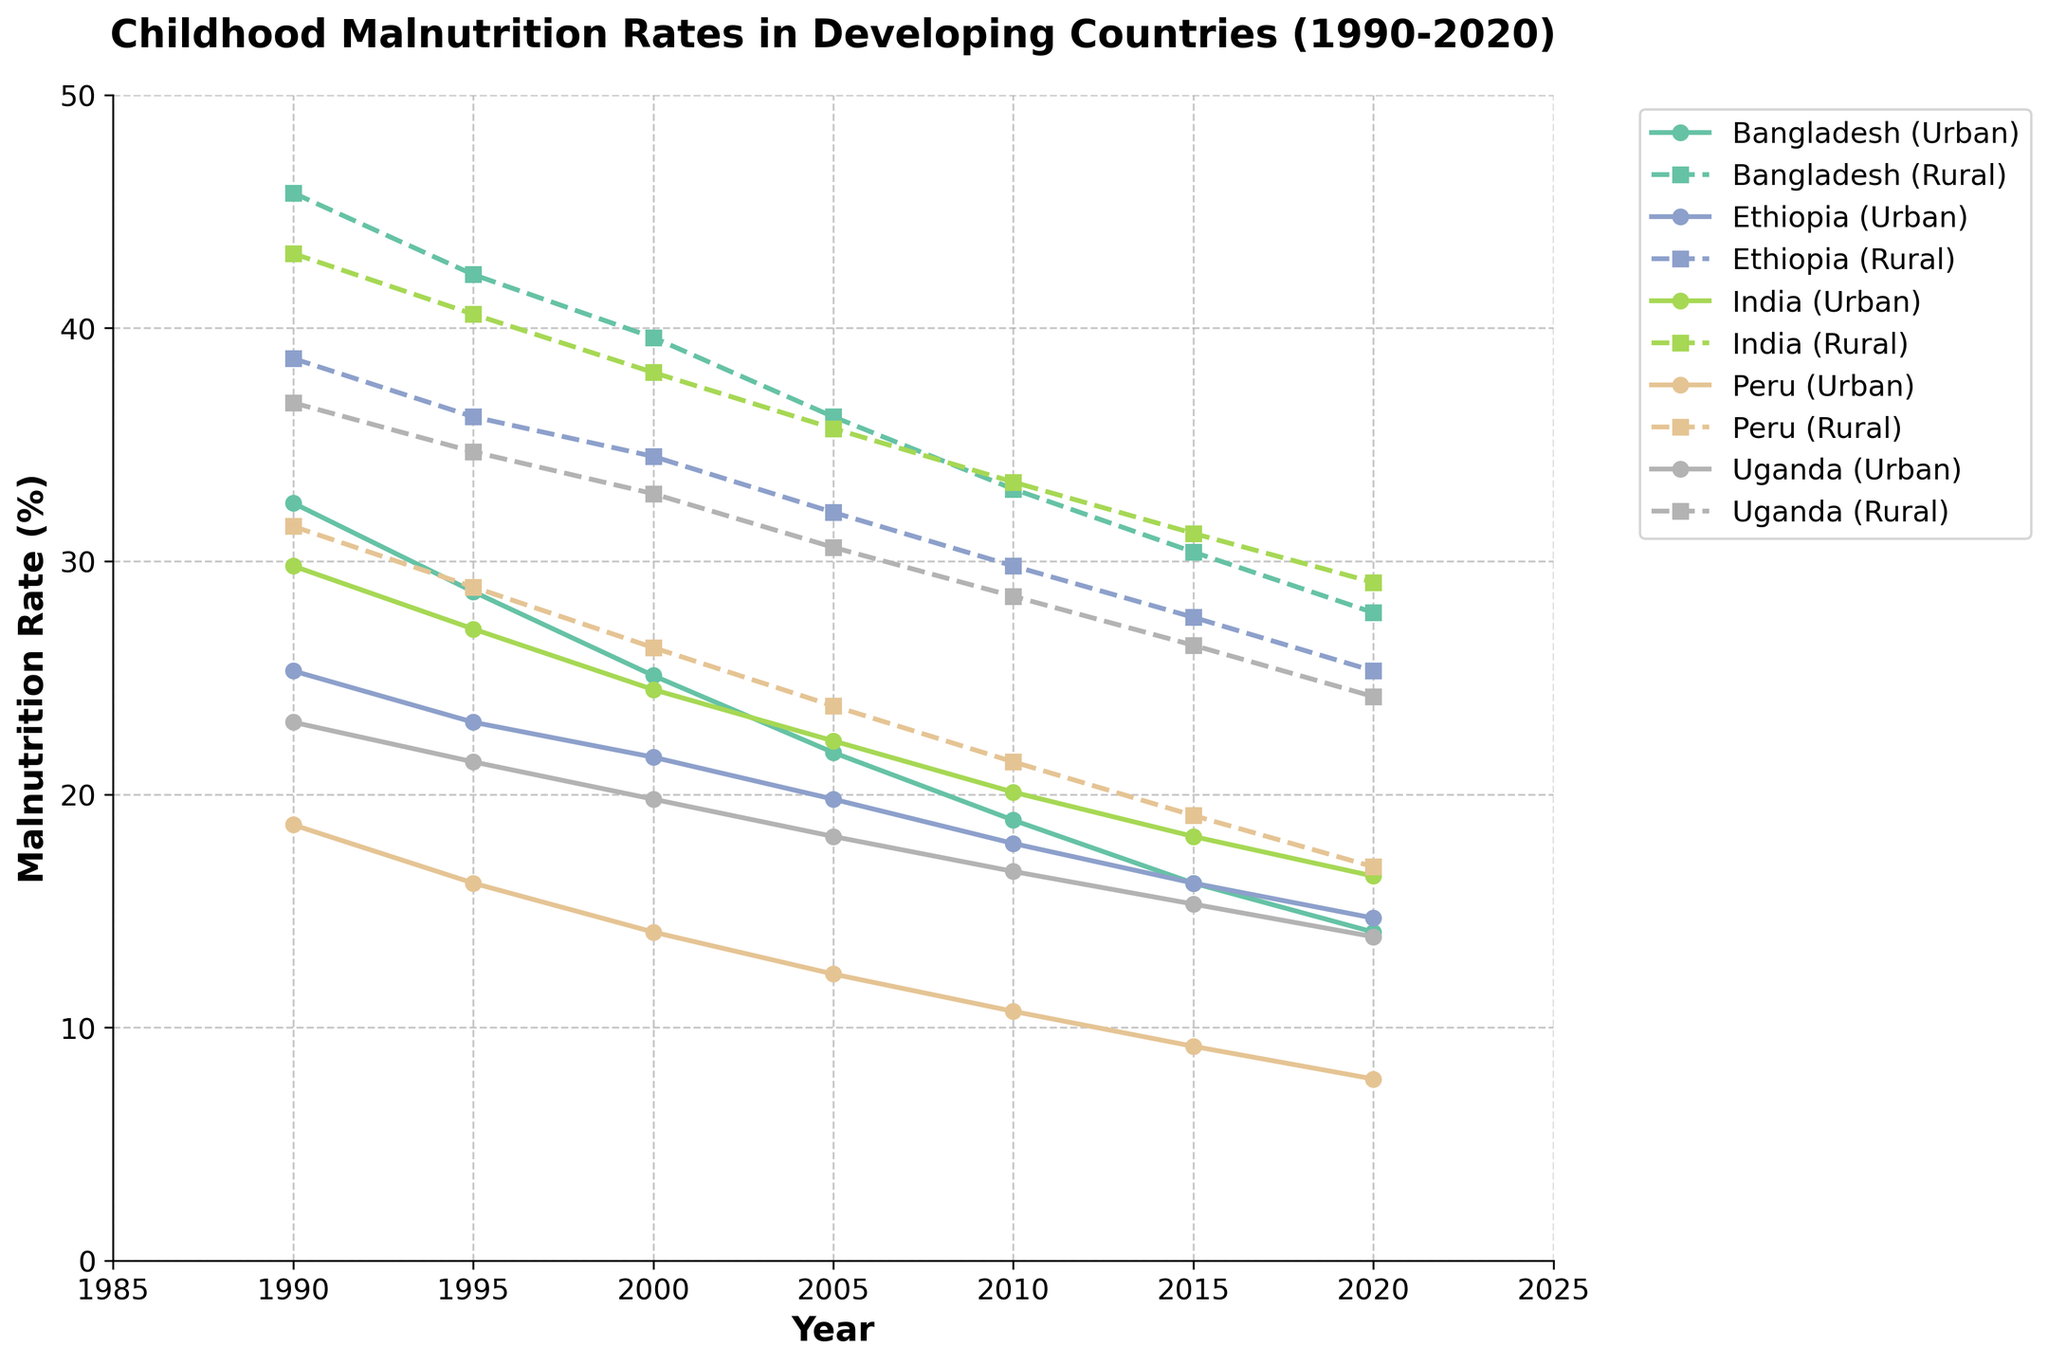What general trend can be observed for both urban and rural childhood malnutrition rates in the countries shown from 1990 to 2020? By examining the plotted lines (both solid and dashed) for each country, we can see that all lines generally show a downward trend, indicating a decrease in childhood malnutrition rates over the period from 1990 to 2020 in both urban and rural areas.
Answer: Decreasing trend Which country had the highest rural malnutrition rate in 1990, and what was the rate? By looking at the highest data point among the dashed lines for the year 1990, we can see that Bangladesh had the highest rural malnutrition rate, which was 45.8%.
Answer: Bangladesh, 45.8% In which year did India’s urban malnutrition rate first drop below 20%? By tracing the solid line for India (Urban) down the year axis, it can be observed that the urban malnutrition rate first dropped below 20% in the year 2010.
Answer: 2010 Between 1990 and 2020, which country had the smallest difference between urban and rural childhood malnutrition rates, and in what year? Calculate the differences for each country for each year shown; Peru in 2020 shows the smallest difference (16.9% - 7.8% = 9.1%).
Answer: Peru, 2020 Compare the urban malnutrition rates of Bangladesh and Peru in the year 2000. Which country had a lower rate, and what was the difference? From the 2000 data points of the solid lines for Bangladesh and Peru, Peru had a lower rate. The malnutrition rates were 25.1% for Bangladesh and 14.1% for Peru. The difference is 25.1% - 14.1% = 11%.
Answer: Peru, 11% How did the rural malnutrition rate in Uganda change from 1990 to 2020? Observing the dashed line for Uganda, the rural malnutrition rate decreased from 36.8% in 1990 to 24.2% in 2020.
Answer: Decreased Which country's rural malnutrition rate was closest to 30% in 2015? By examining the dashed lines for the year 2015, Ethiopia's rural malnutrition rate was 27.6%, which is closest to 30%.
Answer: Ethiopia What has been the average annual rate of decline in urban malnutrition rates for Bangladesh from 1990 to 2020? The decrease in urban malnutrition rate for Bangladesh from 1990 to 2020 is 32.5% - 14.1% = 18.4%. Over 30 years, the average annual rate of decline is 18.4% / 30 = 0.6133% per year.
Answer: 0.61% per year In 2020, identify the country with the smallest urban malnutrition rate and provide the value. By looking at the solid lines in 2020, Peru had the smallest urban malnutrition rate of 7.8%.
Answer: Peru, 7.8% 